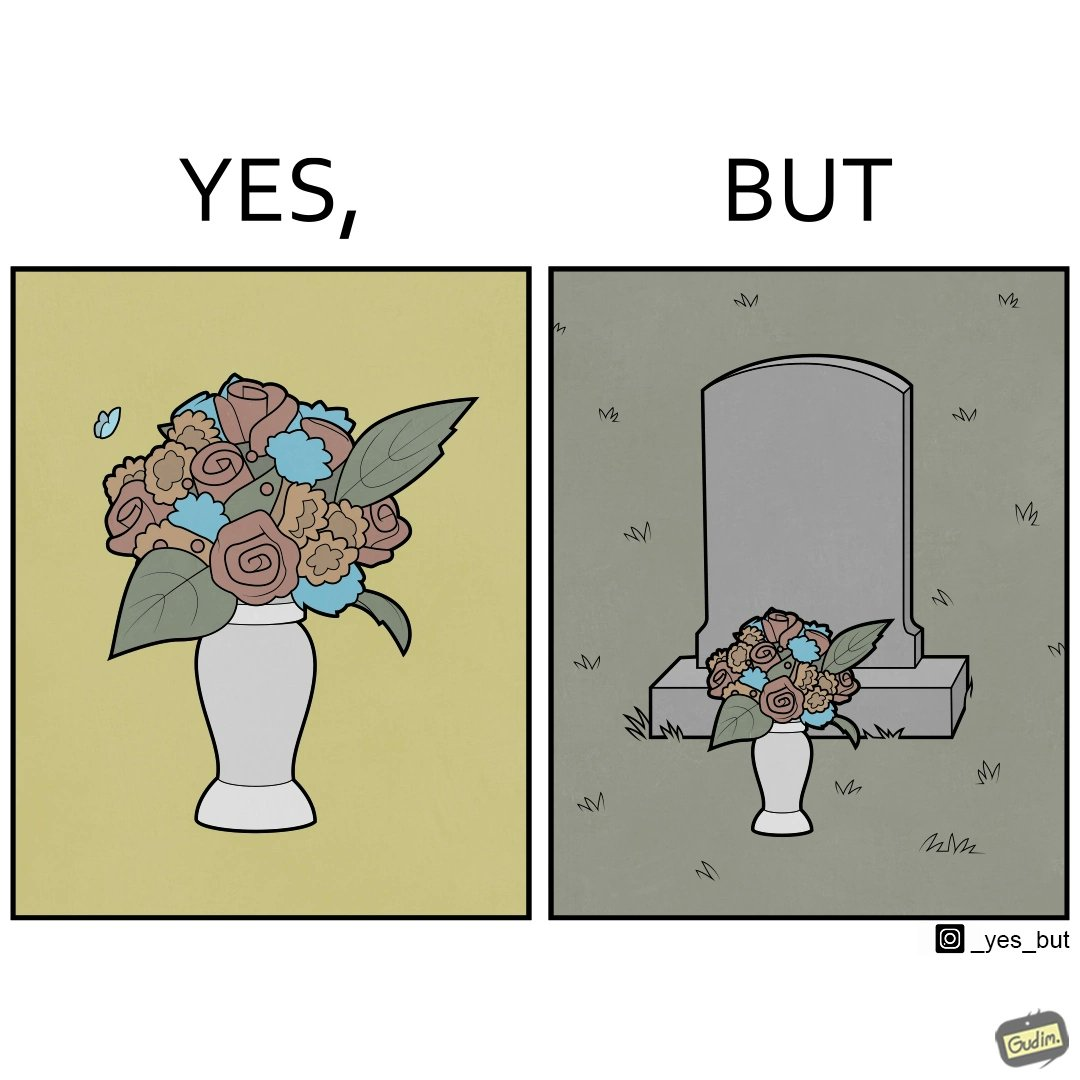Describe the satirical element in this image. The image is ironic, because in the first image a vase full of different beautiful flowers is seen which spreads a feeling of positivity, cheerfulness etc., whereas in the second image when the same vase is put in front of a grave stone it produces a feeling of sorrow 